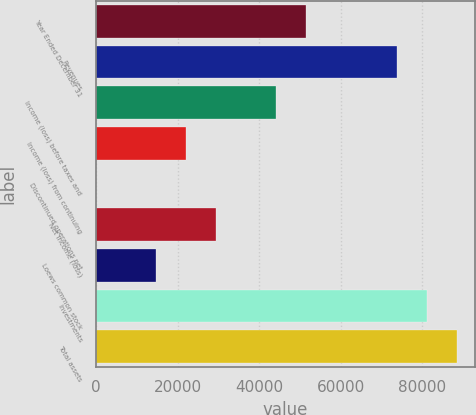Convert chart to OTSL. <chart><loc_0><loc_0><loc_500><loc_500><bar_chart><fcel>Year Ended December 31<fcel>Revenues<fcel>Income (loss) before taxes and<fcel>Income (loss) from continuing<fcel>Discontinued operations net<fcel>Net income (loss)<fcel>Loews common stock<fcel>Investments<fcel>Total assets<nl><fcel>51610.1<fcel>73720.3<fcel>44240<fcel>22129.7<fcel>19.5<fcel>29499.8<fcel>14759.7<fcel>81090.4<fcel>88460.5<nl></chart> 